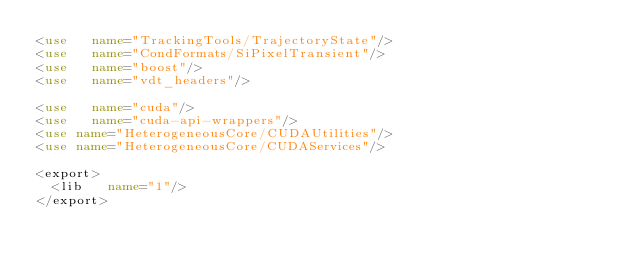Convert code to text. <code><loc_0><loc_0><loc_500><loc_500><_XML_><use   name="TrackingTools/TrajectoryState"/>
<use   name="CondFormats/SiPixelTransient"/>
<use   name="boost"/>
<use   name="vdt_headers"/>

<use   name="cuda"/>
<use   name="cuda-api-wrappers"/>
<use name="HeterogeneousCore/CUDAUtilities"/>
<use name="HeterogeneousCore/CUDAServices"/>

<export>
  <lib   name="1"/>
</export>
</code> 